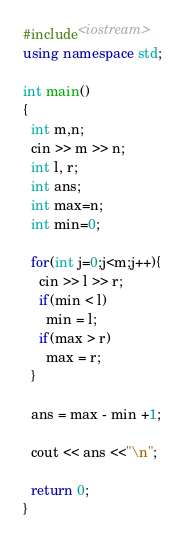<code> <loc_0><loc_0><loc_500><loc_500><_C++_>#include<iostream>
using namespace std;

int main()
{
  int m,n;
  cin >> m >> n;
  int l, r;
  int ans;
  int max=n;
  int min=0;
  
  for(int j=0;j<m;j++){
    cin >> l >> r;
    if(min < l)
      min = l;
    if(max > r)
      max = r;
  }
  
  ans = max - min +1;
  
  cout << ans <<"\n";
  
  return 0;
}

</code> 